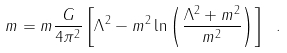Convert formula to latex. <formula><loc_0><loc_0><loc_500><loc_500>m = m \frac { G } { 4 \pi ^ { 2 } } \left [ \Lambda ^ { 2 } - m ^ { 2 } \ln \left ( \frac { \Lambda ^ { 2 } + m ^ { 2 } } { m ^ { 2 } } \right ) \right ] \ .</formula> 